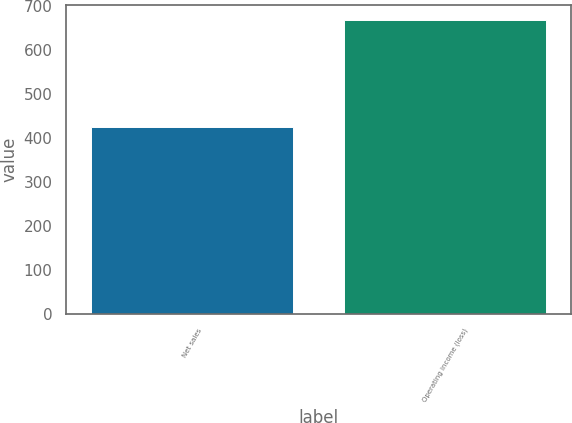Convert chart. <chart><loc_0><loc_0><loc_500><loc_500><bar_chart><fcel>Net sales<fcel>Operating income (loss)<nl><fcel>425<fcel>668<nl></chart> 